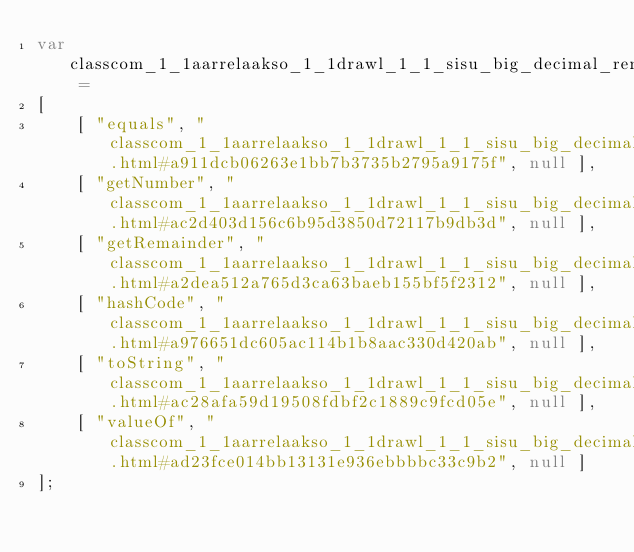Convert code to text. <code><loc_0><loc_0><loc_500><loc_500><_JavaScript_>var classcom_1_1aarrelaakso_1_1drawl_1_1_sisu_big_decimal_remainder_pair =
[
    [ "equals", "classcom_1_1aarrelaakso_1_1drawl_1_1_sisu_big_decimal_remainder_pair.html#a911dcb06263e1bb7b3735b2795a9175f", null ],
    [ "getNumber", "classcom_1_1aarrelaakso_1_1drawl_1_1_sisu_big_decimal_remainder_pair.html#ac2d403d156c6b95d3850d72117b9db3d", null ],
    [ "getRemainder", "classcom_1_1aarrelaakso_1_1drawl_1_1_sisu_big_decimal_remainder_pair.html#a2dea512a765d3ca63baeb155bf5f2312", null ],
    [ "hashCode", "classcom_1_1aarrelaakso_1_1drawl_1_1_sisu_big_decimal_remainder_pair.html#a976651dc605ac114b1b8aac330d420ab", null ],
    [ "toString", "classcom_1_1aarrelaakso_1_1drawl_1_1_sisu_big_decimal_remainder_pair.html#ac28afa59d19508fdbf2c1889c9fcd05e", null ],
    [ "valueOf", "classcom_1_1aarrelaakso_1_1drawl_1_1_sisu_big_decimal_remainder_pair.html#ad23fce014bb13131e936ebbbbc33c9b2", null ]
];</code> 